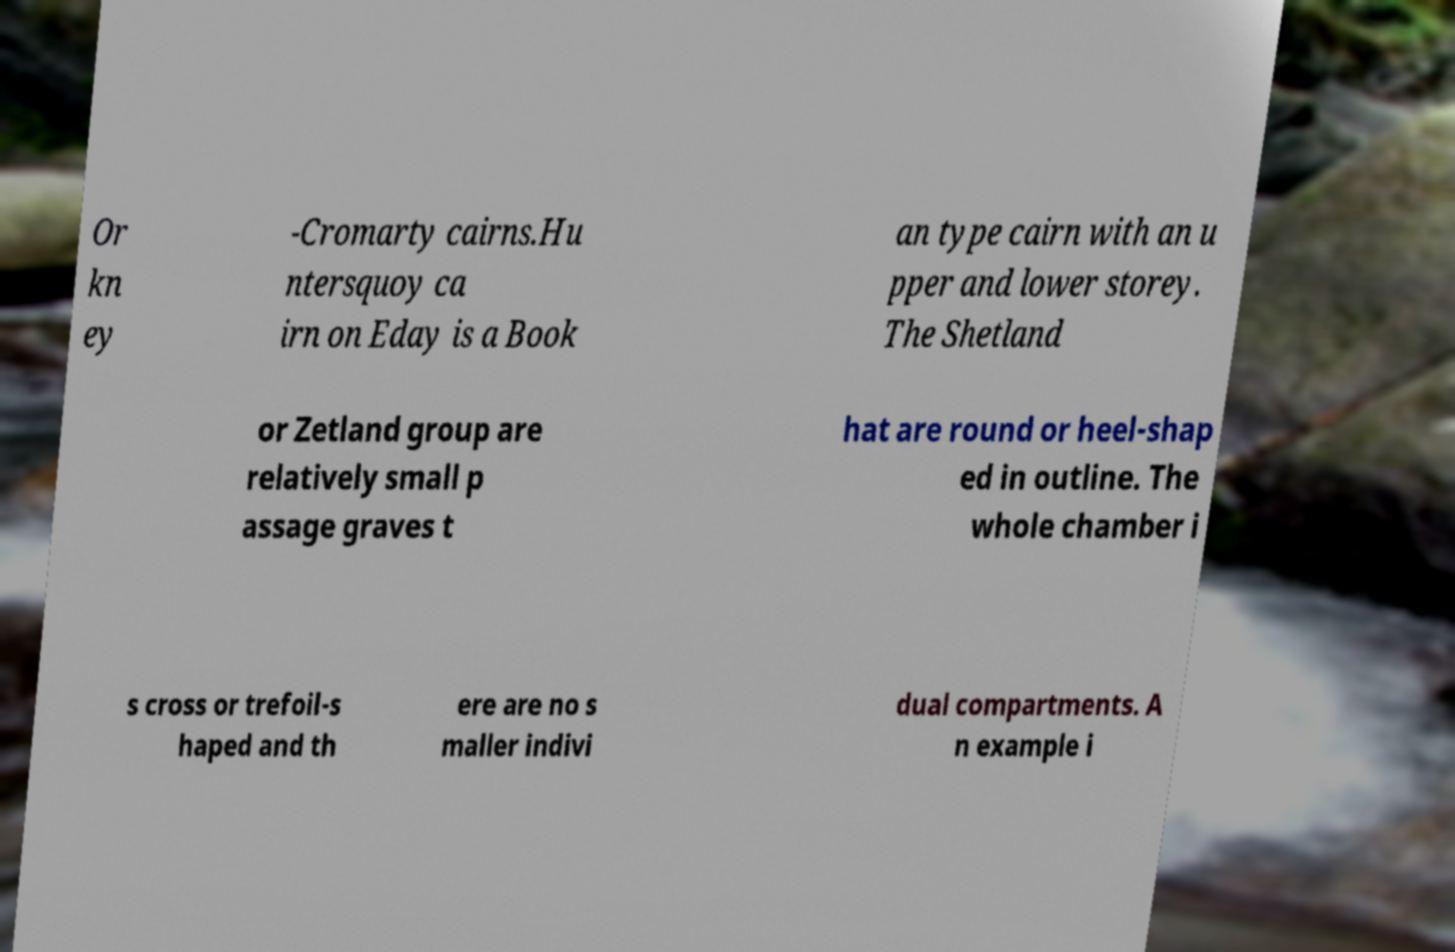Please identify and transcribe the text found in this image. Or kn ey -Cromarty cairns.Hu ntersquoy ca irn on Eday is a Book an type cairn with an u pper and lower storey. The Shetland or Zetland group are relatively small p assage graves t hat are round or heel-shap ed in outline. The whole chamber i s cross or trefoil-s haped and th ere are no s maller indivi dual compartments. A n example i 